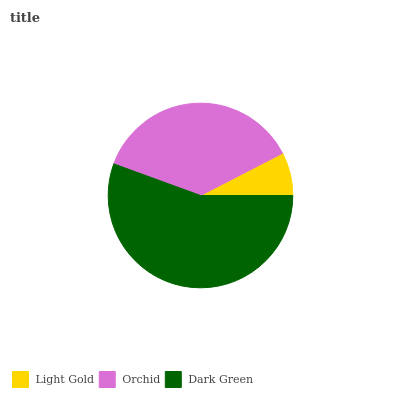Is Light Gold the minimum?
Answer yes or no. Yes. Is Dark Green the maximum?
Answer yes or no. Yes. Is Orchid the minimum?
Answer yes or no. No. Is Orchid the maximum?
Answer yes or no. No. Is Orchid greater than Light Gold?
Answer yes or no. Yes. Is Light Gold less than Orchid?
Answer yes or no. Yes. Is Light Gold greater than Orchid?
Answer yes or no. No. Is Orchid less than Light Gold?
Answer yes or no. No. Is Orchid the high median?
Answer yes or no. Yes. Is Orchid the low median?
Answer yes or no. Yes. Is Dark Green the high median?
Answer yes or no. No. Is Light Gold the low median?
Answer yes or no. No. 